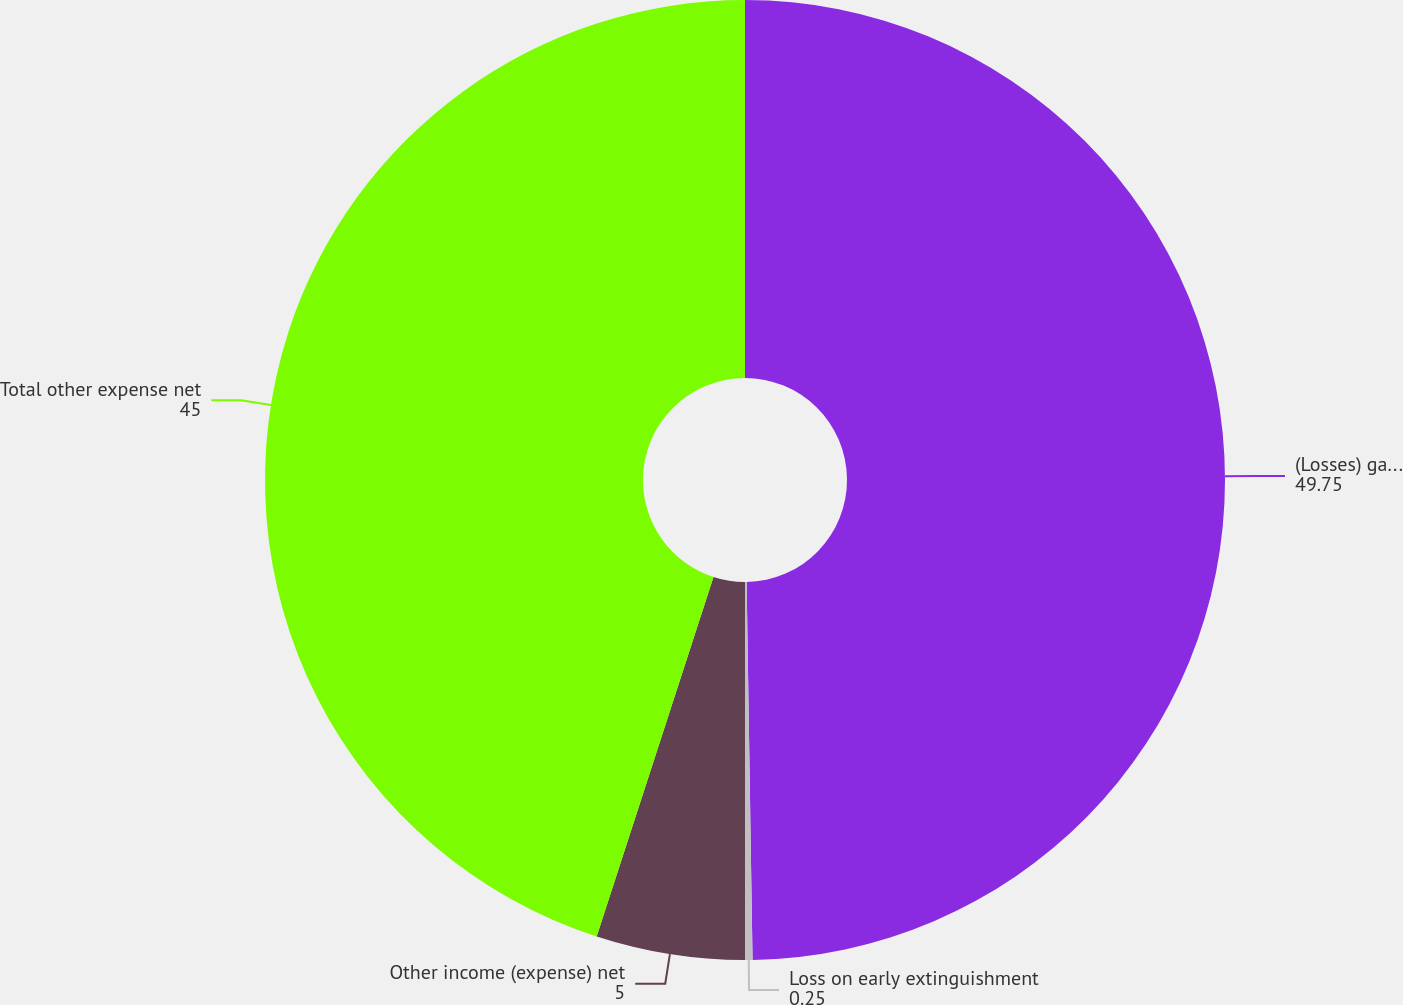Convert chart. <chart><loc_0><loc_0><loc_500><loc_500><pie_chart><fcel>(Losses) gains on sales of<fcel>Loss on early extinguishment<fcel>Other income (expense) net<fcel>Total other expense net<nl><fcel>49.75%<fcel>0.25%<fcel>5.0%<fcel>45.0%<nl></chart> 